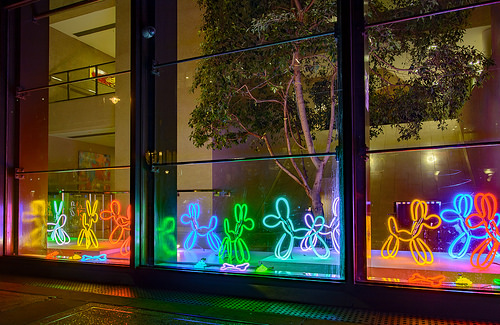<image>
Is the tree behind the window? Yes. From this viewpoint, the tree is positioned behind the window, with the window partially or fully occluding the tree. 